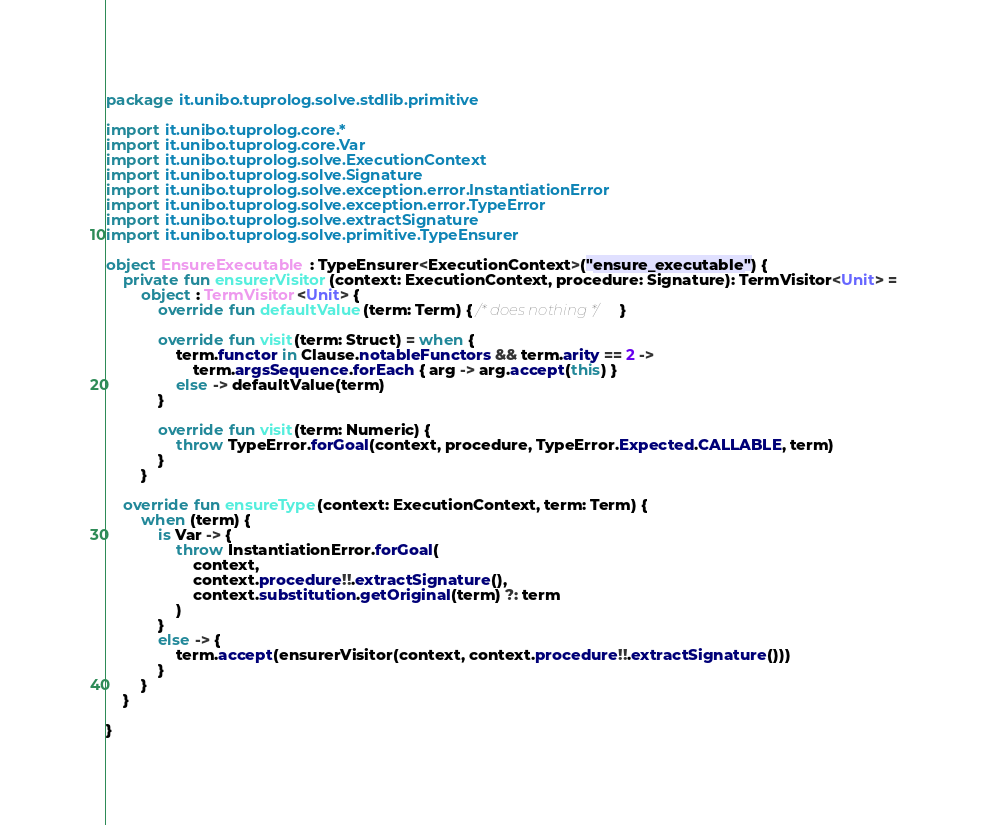<code> <loc_0><loc_0><loc_500><loc_500><_Kotlin_>package it.unibo.tuprolog.solve.stdlib.primitive

import it.unibo.tuprolog.core.*
import it.unibo.tuprolog.core.Var
import it.unibo.tuprolog.solve.ExecutionContext
import it.unibo.tuprolog.solve.Signature
import it.unibo.tuprolog.solve.exception.error.InstantiationError
import it.unibo.tuprolog.solve.exception.error.TypeError
import it.unibo.tuprolog.solve.extractSignature
import it.unibo.tuprolog.solve.primitive.TypeEnsurer

object EnsureExecutable : TypeEnsurer<ExecutionContext>("ensure_executable") {
    private fun ensurerVisitor(context: ExecutionContext, procedure: Signature): TermVisitor<Unit> =
        object : TermVisitor<Unit> {
            override fun defaultValue(term: Term) { /* does nothing */ }

            override fun visit(term: Struct) = when {
                term.functor in Clause.notableFunctors && term.arity == 2 ->
                    term.argsSequence.forEach { arg -> arg.accept(this) }
                else -> defaultValue(term)
            }

            override fun visit(term: Numeric) {
                throw TypeError.forGoal(context, procedure, TypeError.Expected.CALLABLE, term)
            }
        }

    override fun ensureType(context: ExecutionContext, term: Term) {
        when (term) {
            is Var -> {
                throw InstantiationError.forGoal(
                    context,
                    context.procedure!!.extractSignature(),
                    context.substitution.getOriginal(term) ?: term
                )
            }
            else -> {
                term.accept(ensurerVisitor(context, context.procedure!!.extractSignature()))
            }
        }
    }

}</code> 